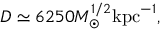<formula> <loc_0><loc_0><loc_500><loc_500>D \simeq 6 2 5 0 M _ { \odot } ^ { 1 / 2 } k p c ^ { - 1 } ,</formula> 